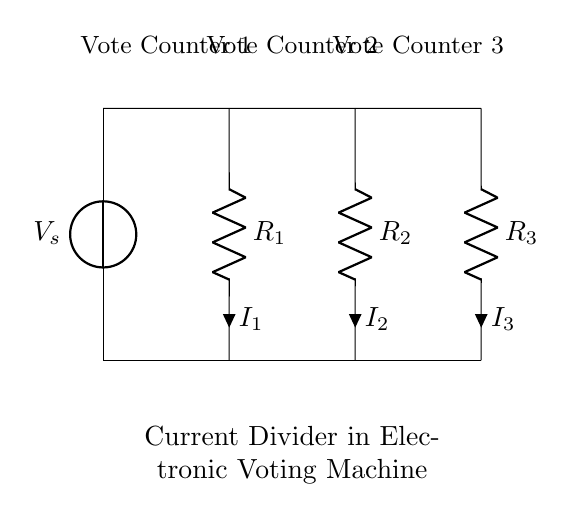What is the source voltage in the circuit? The source voltage is indicated as V_s in the diagram, which is the top voltage source in the circuit.
Answer: V_s How many resistors are present in the current divider? There are three resistors labeled R_1, R_2, and R_3 connected in parallel in the diagram.
Answer: 3 What does the term "current divider" refer to in this circuit? The term "current divider" refers to the configuration where total current from the source splits into separate branches through the resistors, allowing each branch to measure different portions of the total current.
Answer: Splitting current What is the relationship between the currents I_1, I_2, and I_3? The total current entering the parallel circuit is divided among the three branches following the formula I_total = I_1 + I_2 + I_3, reflecting how current divides according to each resistor's value.
Answer: I_total = I_1 + I_2 + I_3 If R_1 is 4 ohms and R_2 is 2 ohms, what can be inferred about the currents I_1 and I_2? Current through a resistor is inversely proportional to its resistance in a parallel circuit, therefore I_1 will be less than I_2 because R_1 is greater than R_2.
Answer: I_1 < I_2 Which component allows for secure tallying of votes in this circuit? The resistors, as they manage and divide the current precisely, lead to reliable readings in the vote counters, ensuring accurate vote tallying.
Answer: Resistors 